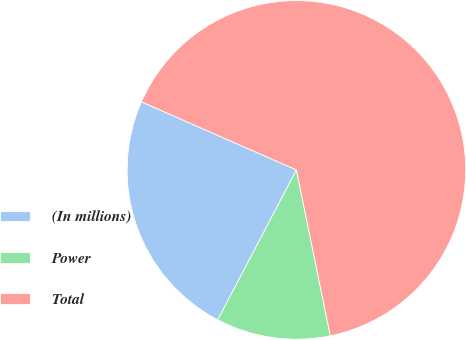Convert chart. <chart><loc_0><loc_0><loc_500><loc_500><pie_chart><fcel>(In millions)<fcel>Power<fcel>Total<nl><fcel>23.9%<fcel>10.9%<fcel>65.21%<nl></chart> 